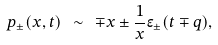<formula> <loc_0><loc_0><loc_500><loc_500>p _ { \pm } ( x , t ) \ \sim \ \mp x \pm \frac { 1 } { x } \epsilon _ { \pm } ( t \mp q ) ,</formula> 